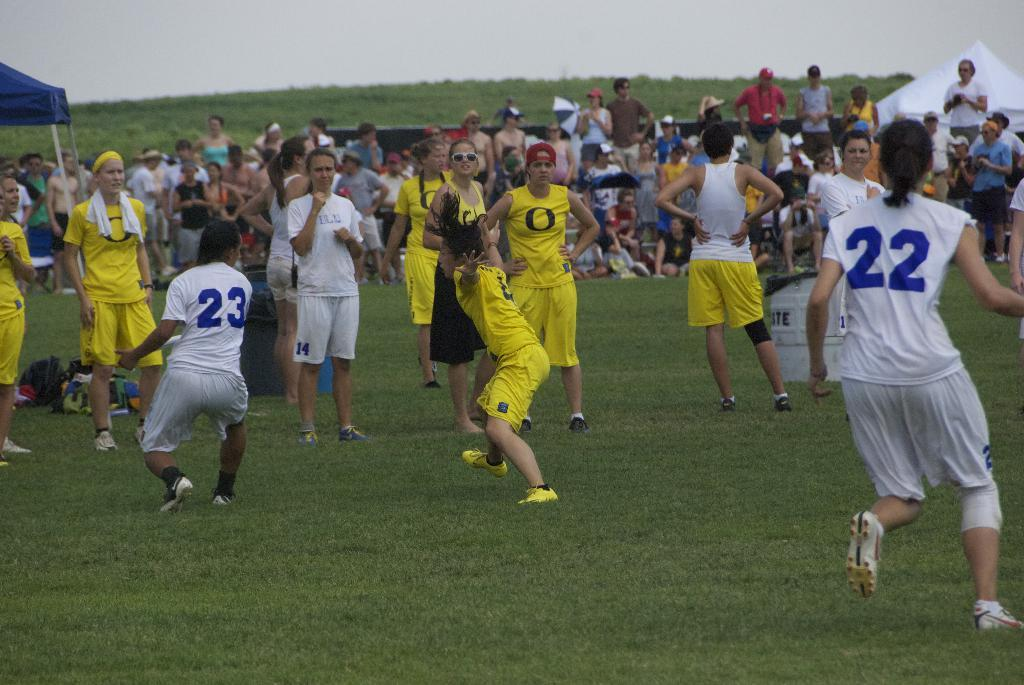<image>
Give a short and clear explanation of the subsequent image. A person in a white uniform has the number 22 on the back and is on a field with other players. 